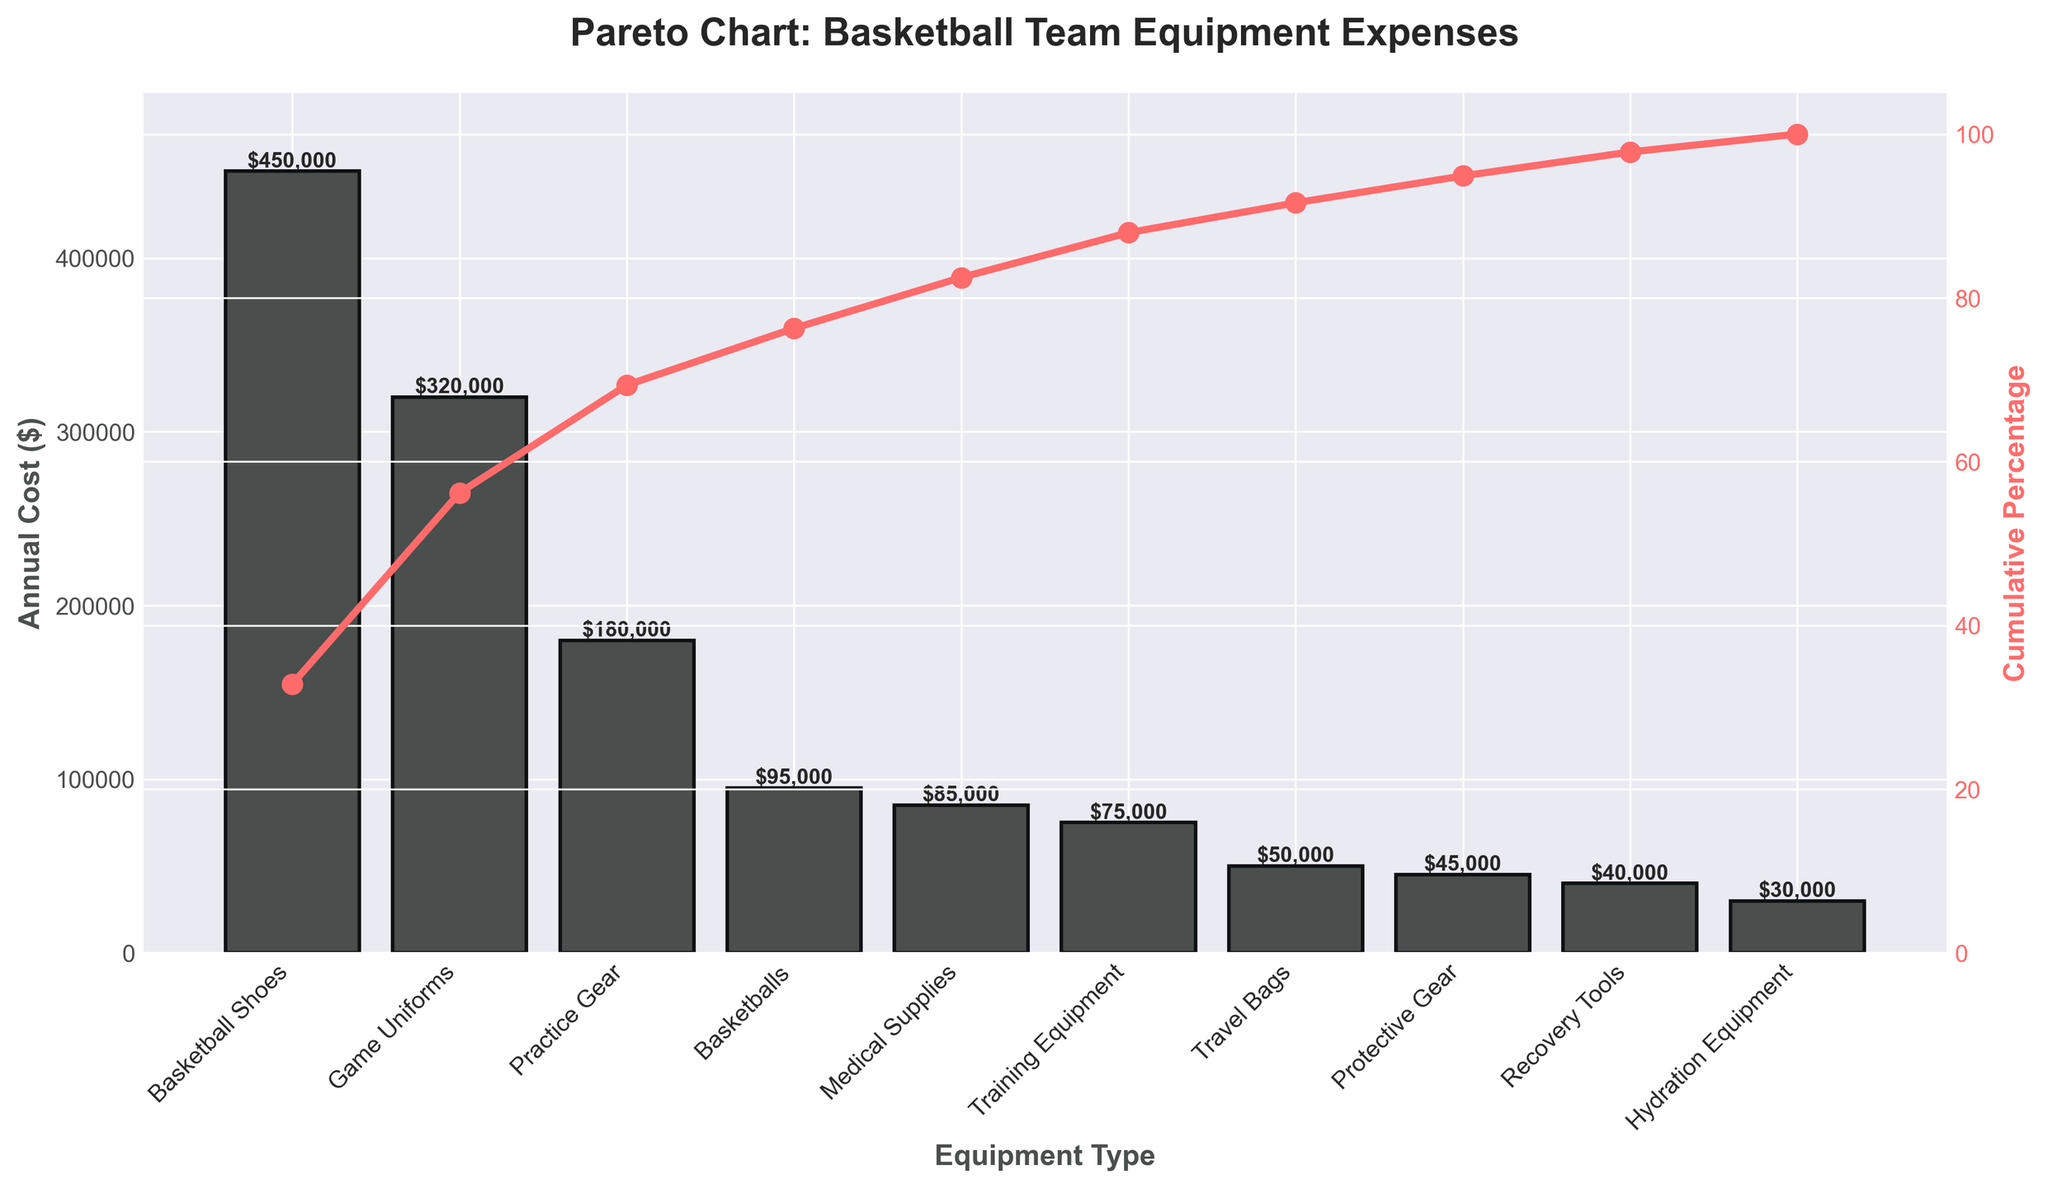What is the title of the chart? The title is usually found at the top of the chart and represents the overall subject of the chart.
Answer: Pareto Chart: Basketball Team Equipment Expenses What are the two y-axes representing? The left y-axis represents the annual cost in dollars, while the right y-axis represents the cumulative percentage. Network with lines and bars on the chart give this away.
Answer: Annual Cost ($) and Cumulative Percentage Which equipment has the highest annual cost? The first bar in the bar chart represents the equipment with the highest annual cost. It is also labeled at the top of the bar.
Answer: Basketball Shoes What is the cumulative percentage for Game Uniforms? The cumulative percentage line (red) and marker over the Game Uniforms bar shows its cumulative percentage.
Answer: Approximately 50% How many equipment types have an annual cost below $100,000? Count the bars whose heights are below the $100,000 line on the left y-axis.
Answer: 6 What is the total annual cost of Basketball Shoes and Game Uniforms combined? Add the annual costs of Basketball Shoes and Game Uniforms, which are the first two bars: $450,000 + $320,000.
Answer: $770,000 Which equipment types cumulatively account for 80% of the total cost? Check which cumulative percentage marker first crosses the 80% mark on the right y-axis and see what equipment types are included up to that point.
Answer: Basketball Shoes, Game Uniforms, and Practice Gear Is the annual cost of Medical Supplies more or less than Recovery Tools? Compare the heights of the bars labeled Medical Supplies and Recovery Tools.
Answer: More What is the difference in annual cost between Protective Gear and Travel Bags? Subtract the annual cost of Protective Gear from Travel Bags: $50,000 - $45,000.
Answer: $5,000 At what percentage does the Cumulative % line start? The red cumulative percentage line starts at 0% as the first marker at Basketball Shoes shows the initial value before accumulation.
Answer: 0% 